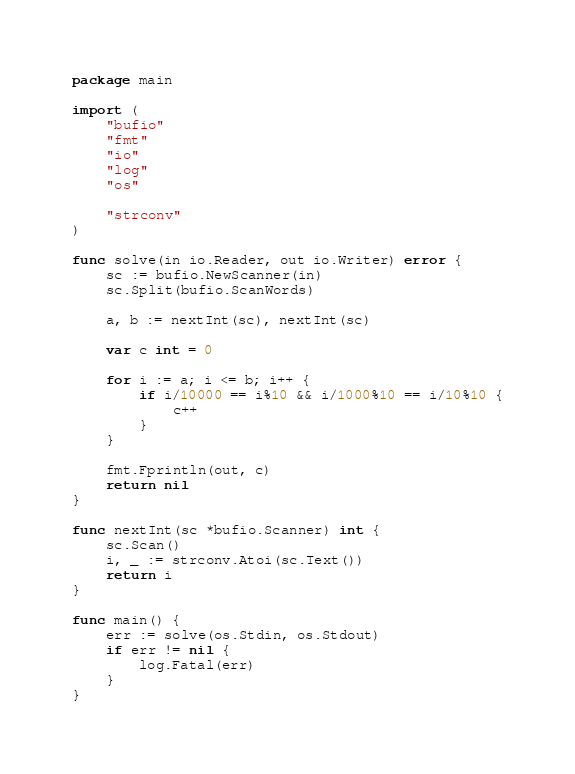Convert code to text. <code><loc_0><loc_0><loc_500><loc_500><_Go_>package main

import (
	"bufio"
	"fmt"
	"io"
	"log"
	"os"

	"strconv"
)

func solve(in io.Reader, out io.Writer) error {
	sc := bufio.NewScanner(in)
	sc.Split(bufio.ScanWords)

	a, b := nextInt(sc), nextInt(sc)

	var c int = 0

	for i := a; i <= b; i++ {
		if i/10000 == i%10 && i/1000%10 == i/10%10 {
			c++
		}
	}

	fmt.Fprintln(out, c)
	return nil
}

func nextInt(sc *bufio.Scanner) int {
	sc.Scan()
	i, _ := strconv.Atoi(sc.Text())
	return i
}

func main() {
	err := solve(os.Stdin, os.Stdout)
	if err != nil {
		log.Fatal(err)
	}
}
</code> 